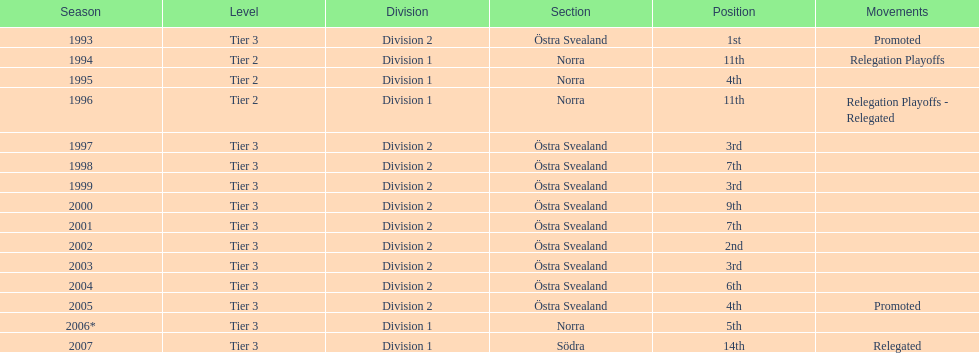What is specified under the movements column of the final season? Relegated. 